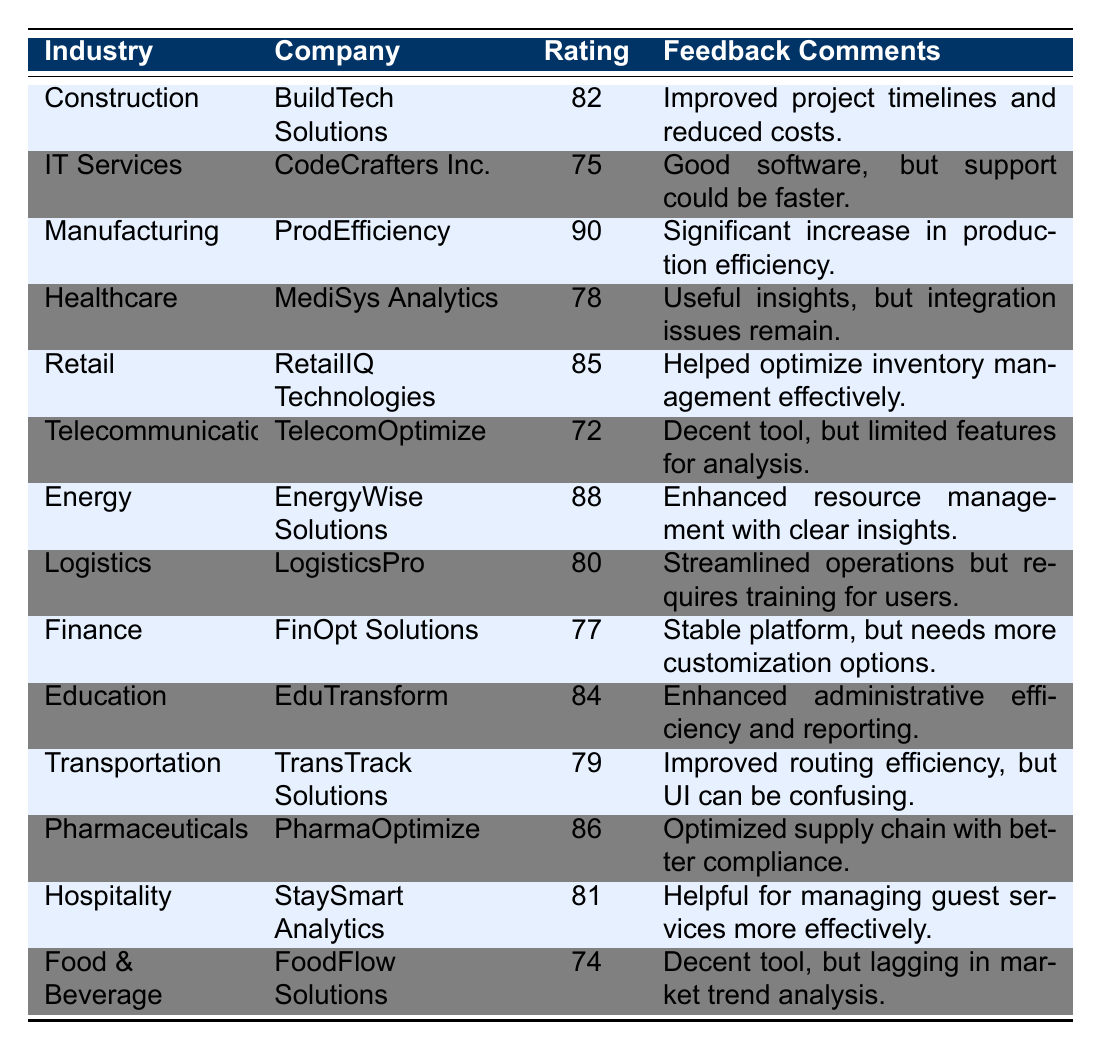What is the highest customer satisfaction rating among the companies listed? The table shows each company's customer satisfaction rating, and by examining the ratings, we see that 'ProdEfficiency' in the Manufacturing industry has the highest rating of 90.
Answer: 90 Which company has the lowest customer satisfaction rating? Looking at the ratings in the table, 'TelecomOptimize' in the Telecommunications industry has the lowest rating, which is 72.
Answer: 72 How many companies have a customer satisfaction rating above 80? By reviewing the table, I count the companies with ratings above 80: 'BuildTech Solutions' (82), 'ProdEfficiency' (90), 'RetailIQ Technologies' (85), 'EnergyWise Solutions' (88), 'PharmaOptimize' (86), 'EduTransform' (84), and 'StaySmart Analytics' (81). This gives a total of 7 companies.
Answer: 7 What is the average customer satisfaction rating for the Healthcare, Education, and Retail industries? The ratings for these industries are as follows: Healthcare - 78, Education - 84, Retail - 85. To find the average, sum the ratings (78 + 84 + 85 = 247) and then divide by the number of industries (3), yielding an average rating of 247/3 = 82.33.
Answer: 82.33 Is there a company that received feedback for having integration issues? The table shows that 'MediSys Analytics' in Healthcare includes feedback mentioning integration issues. Therefore, the statement is true.
Answer: Yes Which industry had a company that improved project timelines and reduced costs? According to the feedback provided in the table, 'BuildTech Solutions' from the Construction industry mentioned improvements in project timelines and cost reduction.
Answer: Construction What is the difference between the highest and lowest customer satisfaction ratings? The highest rating (90 from ProdEfficiency) and the lowest rating (72 from TelecomOptimize) can be used to calculate the difference: 90 - 72 = 18.
Answer: 18 Which two industries have ratings that are within 5 points of each other? Upon examining the ratings, 'StaySmart Analytics' (81) in Hospitality and 'LogisticsPro' (80) in Logistics have ratings that are 1 point apart.
Answer: Hospitality and Logistics Are there more companies with ratings above 80 or below 80? Counting the companies with ratings above 80 yields 7 ('BuildTech Solutions', 'ProdEfficiency', 'RetailIQ Technologies', 'EnergyWise Solutions', 'PharmaOptimize', 'EduTransform', 'StaySmart Analytics'). The companies below 80 are 'CodeCrafters Inc.' (75), 'TelecomOptimize' (72), 'FinOpt Solutions' (77), 'MediSys Analytics' (78), 'FoodFlow Solutions' (74), which total 5. As 7 is greater than 5, there are more companies above 80.
Answer: More above 80 Which company has feedback indicating it is useful for managing guest services? Checking the feedback, 'StaySmart Analytics' in Hospitality is indicated as being helpful for managing guest services effectively.
Answer: StaySmart Analytics 